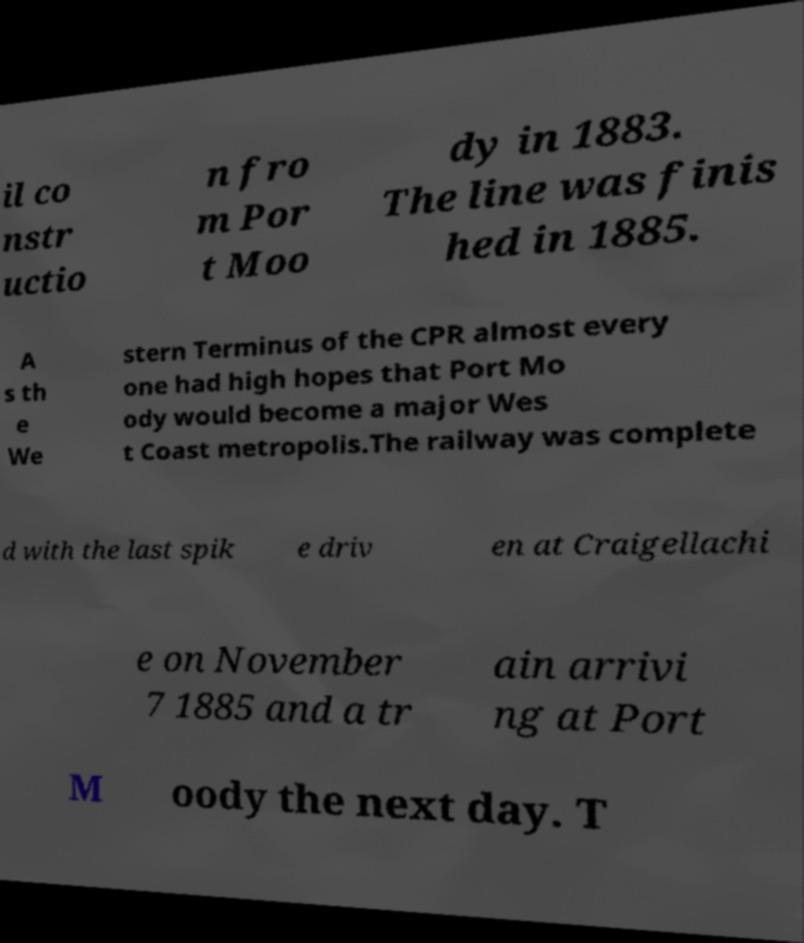There's text embedded in this image that I need extracted. Can you transcribe it verbatim? il co nstr uctio n fro m Por t Moo dy in 1883. The line was finis hed in 1885. A s th e We stern Terminus of the CPR almost every one had high hopes that Port Mo ody would become a major Wes t Coast metropolis.The railway was complete d with the last spik e driv en at Craigellachi e on November 7 1885 and a tr ain arrivi ng at Port M oody the next day. T 